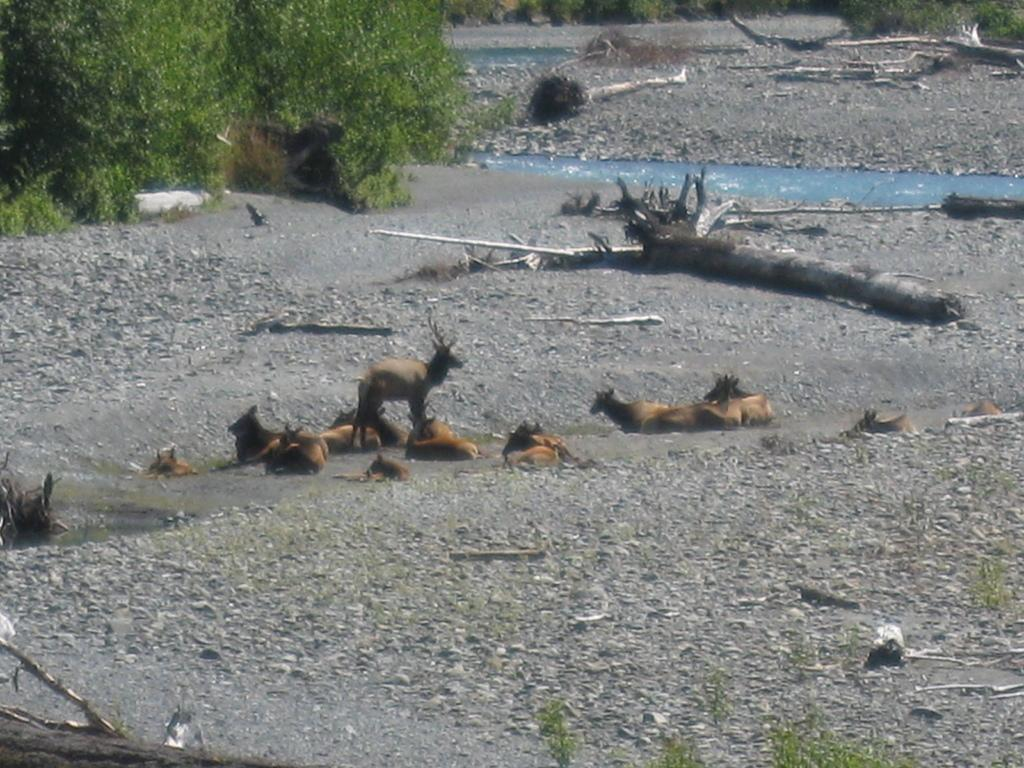What type of animals can be seen in the image? There are animals on the ground in the image. What is visible in the image besides the animals? There is water and wooden logs visible in the image. What can be seen in the background of the image? Surrounding trees are present in the image. What type of meat is being served in the image? There is no meat present in the image; it features animals on the ground, water, wooden logs, and surrounding trees. 